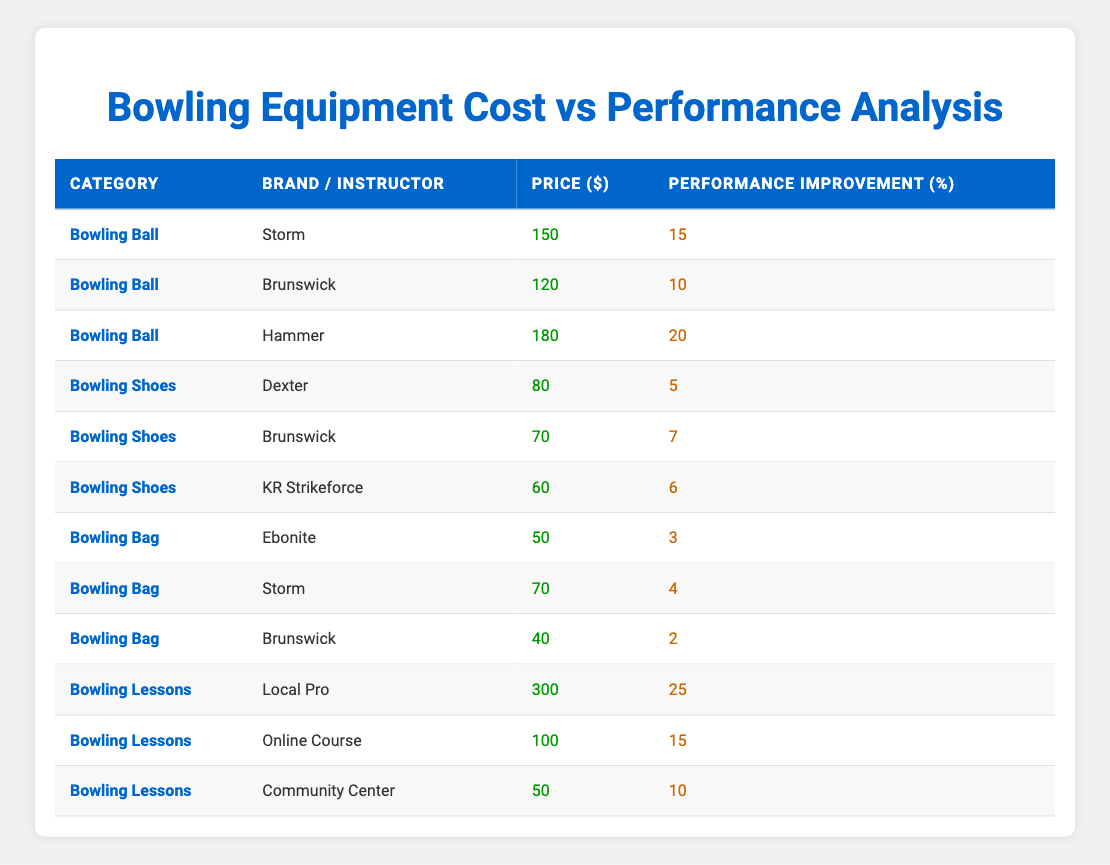What is the price of the most expensive bowling ball? The most expensive bowling ball listed is 'Hammer', which has a price of 180 dollars.
Answer: 180 How much improvement in performance can be expected from taking lessons with the Local Pro? The performance improvement from taking lessons with the Local Pro is 25 percent, as indicated in the table.
Answer: 25% Which bowling shoes offer the least performance improvement? The bowling shoes 'Dexter' offer the least performance improvement of 5 percent, compared to the others listed.
Answer: 5 What is the average price of all bowling bags listed? There are three bowling bags listed with prices of 50, 70, and 40 dollars. The sum is 50 + 70 + 40 = 160. The average is 160/3 = approximately 53.33 dollars.
Answer: 53.33 Does the price of 'Brunswick' bowling shoes provide a better performance improvement percentage than 'KR Strikeforce'? 'Brunswick' bowling shoes are priced at 70 dollars with a performance improvement of 7 percent, while 'KR Strikeforce' are priced at 60 dollars with an improvement of 6 percent. Thus, yes, 'Brunswick' offers better performance improvement.
Answer: Yes Which category generally shows the highest performance improvement percentage? Looking at the table, 'Bowling Lessons' show the highest performance improvements, particularly with the Local Pro offering 25 percent. The other categories do not exceed this number.
Answer: Bowling Lessons If I spend 150 dollars on a bowling ball, what performance improvement can I expect? The alternatives in the bowling ball category indicate 'Storm' for 150 dollars with a performance improvement of 15 percent. Thus, if I spend that amount, I can expect a 15 percent performance improvement.
Answer: 15 What is the total amount spent if I buy one of each listed bowling lesson option? For the bowling lessons, the prices are 300, 100, and 50 dollars. The total is 300 + 100 + 50 = 450 dollars.
Answer: 450 Is the performance improvement percentage from 'Brunswick' bowling lessons better than that from 'Community Center'? 'Brunswick' bowling lessons offer a performance improvement of 15 percent while 'Community Center' offers 10 percent. Therefore, yes, 'Brunswick' has a better performance improvement percentage.
Answer: Yes 